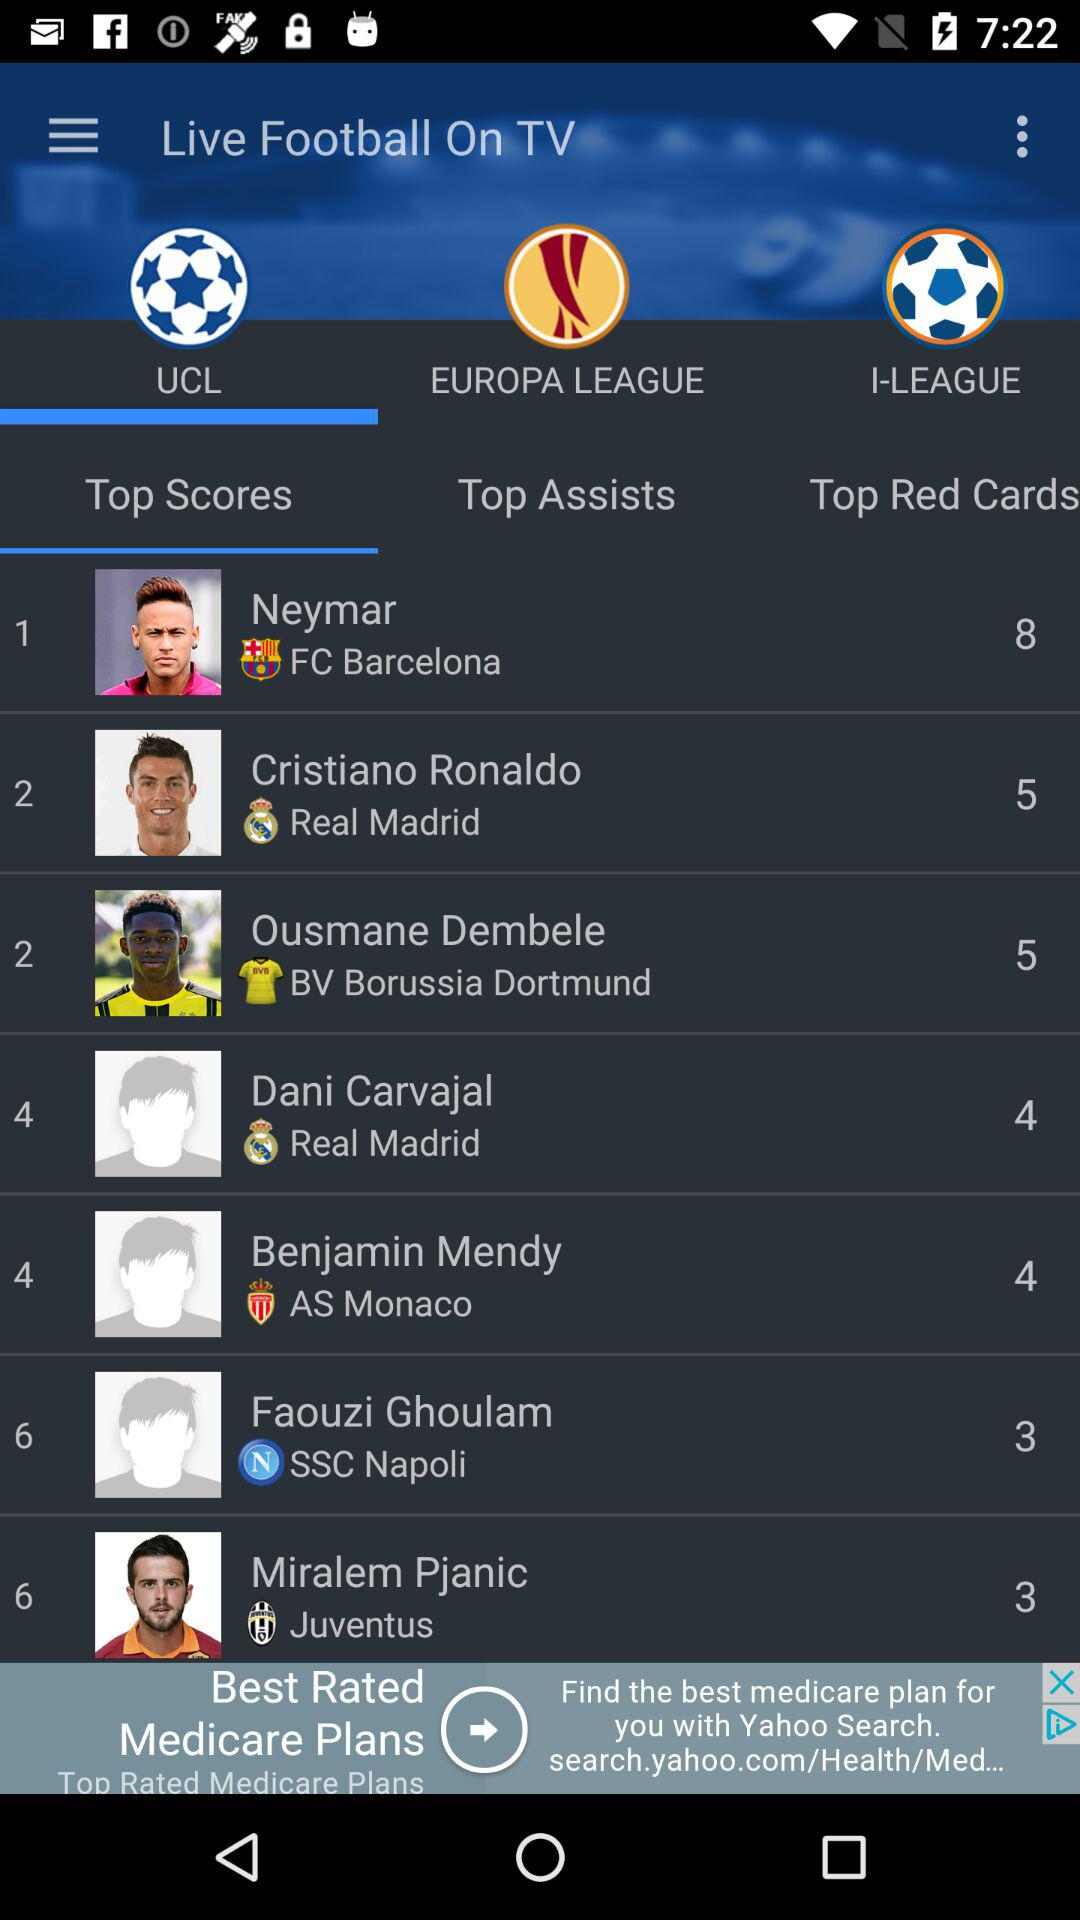What is the selected tab? The selected tabs are "UCL" and "Top Scores". 